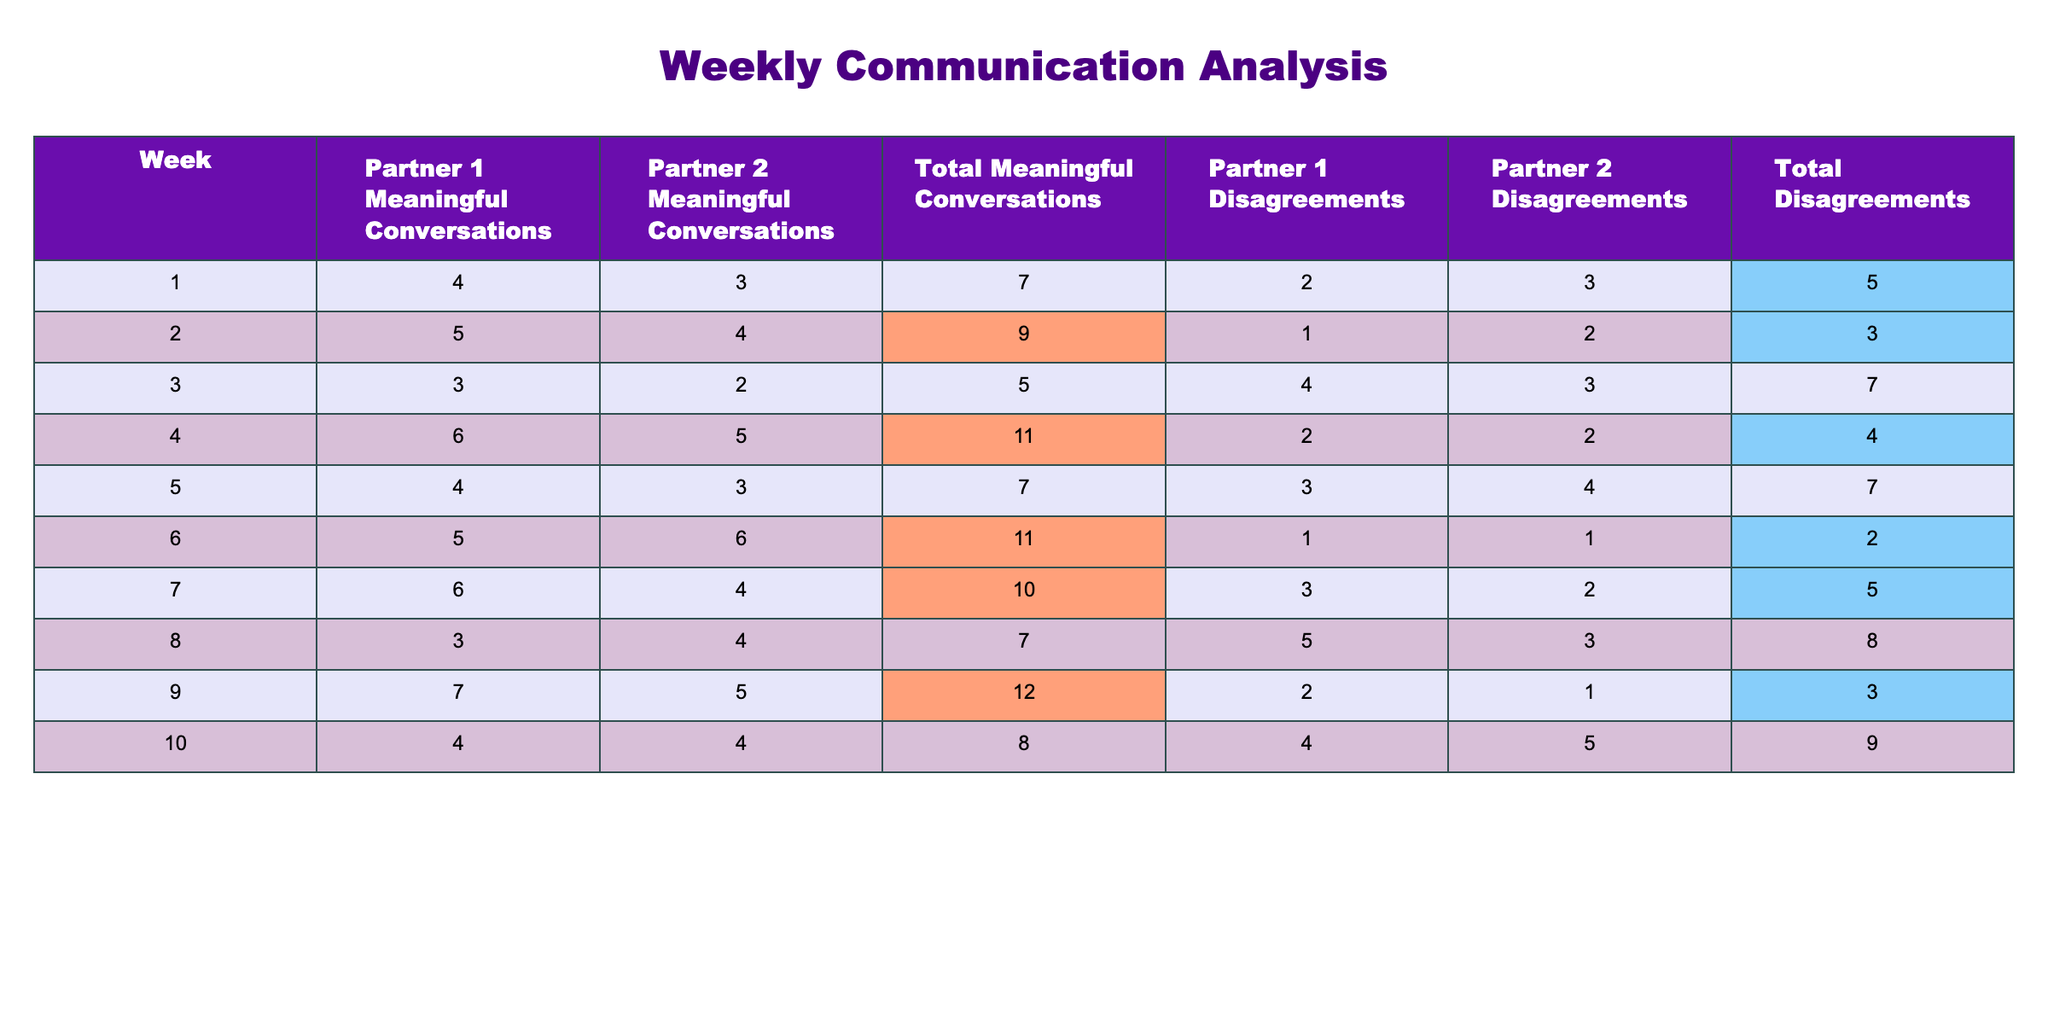What was the highest number of total meaningful conversations recorded in a week? Looking at the "Total Meaningful Conversations" row, the maximum value is 12, which occurred in Week 9.
Answer: 12 Which week had the lowest total disagreements? The "Total Disagreements" row shows that Week 6 had the lowest value of 2.
Answer: 2 What was the average number of meaningful conversations over the ten weeks? To find the average, sum all total meaningful conversations (7 + 9 + 5 + 11 + 7 + 11 + 10 + 7 + 12 + 8 =  88) and divide by 10 weeks: 88/10 = 8.8.
Answer: 8.8 In which week did Partner 1 and Partner 2 have the same number of meaningful conversations? The table shows that in Week 10, Partner 1 and Partner 2 both had 4 meaningful conversations.
Answer: Week 10 Did the number of disagreements in Week 3 exceed the average disagreements for all weeks? First, calculate the average disagreements: (5 + 3 + 7 + 4 + 7 + 2 + 5 + 8 + 3 + 9 = 53), then divide by 10 weeks: 53/10 = 5.3. Week 3 had 7 disagreements, which exceeds 5.3.
Answer: Yes Is there a trend where more meaningful conversations correlate with fewer disagreements? Analyzing the data, Weeks with higher conversations (Weeks 6, 4, and 9) show lower disagreement counts compared to other weeks. This indicates a negative correlation.
Answer: Yes What is the difference between the highest and lowest total disagreements? The highest total disagreements recorded is 9 (Week 10) and the lowest is 2 (Week 6). The difference is 9 - 2 = 7.
Answer: 7 How many weeks had total meaningful conversations above the average? The average of total meaningful conversations is 8.8. Weekend weeks with values higher than 8.8 are Weeks 2, 4, 6, 9, and 10, totaling 5 weeks.
Answer: 5 Which partner had more meaningful conversations in Week 7? In Week 7, Partner 1 had 6 conversations, while Partner 2 had 4, indicating Partner 1 had more.
Answer: Partner 1 Have the total disagreements increased from Week 2 to Week 3? Week 2 had 3 total disagreements and Week 3 had 7 total disagreements, indicating an increase of 4.
Answer: Yes In the weeks where total disagreements were below average, how many meaningful conversations were recorded? The average of total disagreements is 5.3. Weeks with below-average disagreements correspond to Weeks 1, 2, 4, 6, and 9, which totaled to meaningful conversations of 7 + 9 + 11 + 11 + 12 = 50.
Answer: 50 